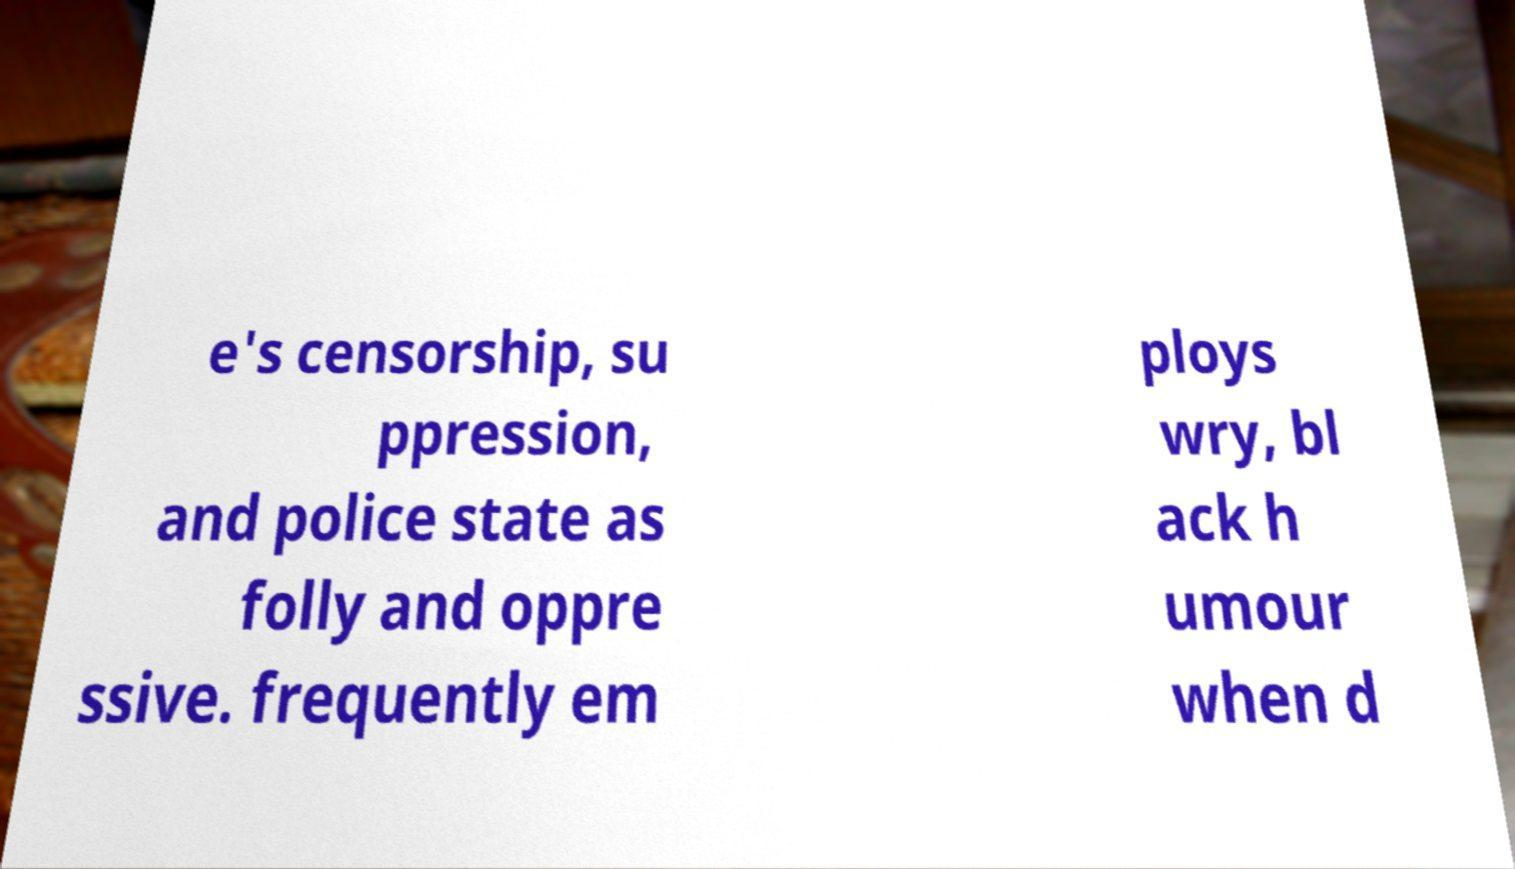Could you extract and type out the text from this image? e's censorship, su ppression, and police state as folly and oppre ssive. frequently em ploys wry, bl ack h umour when d 